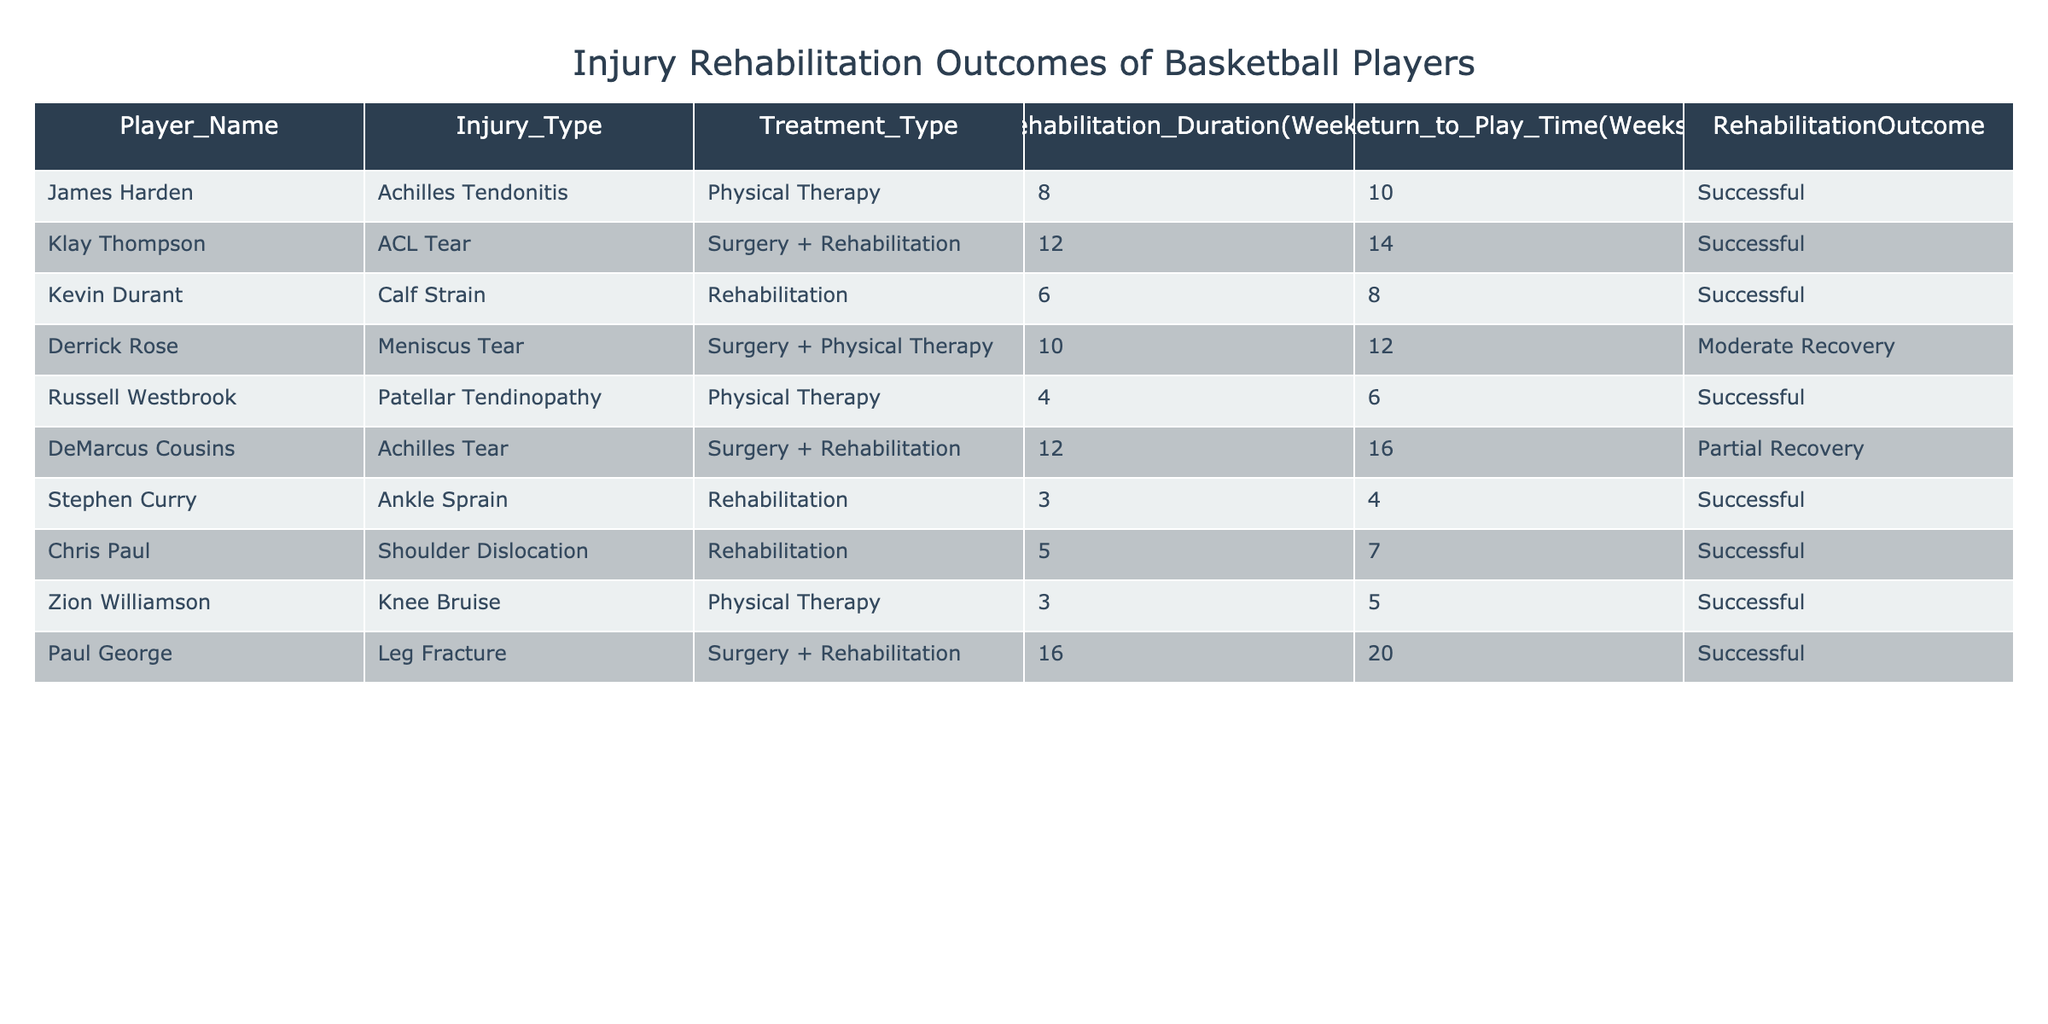What was the rehabilitation duration for Stephen Curry? The table lists Stephen Curry with an injury and provides his rehabilitation duration of 3 weeks.
Answer: 3 weeks How many players had a successful rehabilitation outcome? The table shows that there are 6 players with a "Successful" outcome: James Harden, Kevin Durant, Russell Westbrook, Stephen Curry, Chris Paul, and Zion Williamson.
Answer: 6 players What is the average return to play time for players undergoing surgery + rehabilitation? The return to play weeks for players with surgery + rehabilitation are 14 (Klay Thompson), 16 (DeMarcus Cousins), and 20 (Paul George). Summing these values gives a total of 50 weeks. Dividing by the 3 players, the average return to play time is 50/3, which equals approximately 16.67 weeks.
Answer: 16.67 weeks Did any player with a calf strain have a rehabilitation outcome listed as partial recovery? According to the table, Kevin Durant, who had a calf strain, has a successful outcome and there is no player with this injury type listed as having a partial recovery.
Answer: No What are the total weeks of rehabilitation duration for all players with successful outcomes? The players with successful outcomes are James Harden (8 weeks), Kevin Durant (6 weeks), Russell Westbrook (4 weeks), Stephen Curry (3 weeks), Chris Paul (5 weeks), and Zion Williamson (3 weeks). Adding these values together gives a total of 29 weeks (8 + 6 + 4 + 3 + 5 + 3 = 29).
Answer: 29 weeks Which injury type had the longest rehabilitation duration and what was the duration? The entry with the longest rehabilitation duration is Paul George's leg fracture, which took 16 weeks in total as listed in the table.
Answer: Leg Fracture, 16 weeks How many players returned to play within 6 weeks of rehabilitation? The table shows two players, Russell Westbrook with 6 weeks and Stephen Curry with 4 weeks, who returned to play within 6 weeks after rehabilitation.
Answer: 2 players Is there a player who had a successful outcome and also underwent surgery and physical therapy? The table indicates that Derrick Rose had surgery and physical therapy, but his outcome is noted as moderate recovery, not successful. Therefore, there is no player fitting this criterion.
Answer: No 